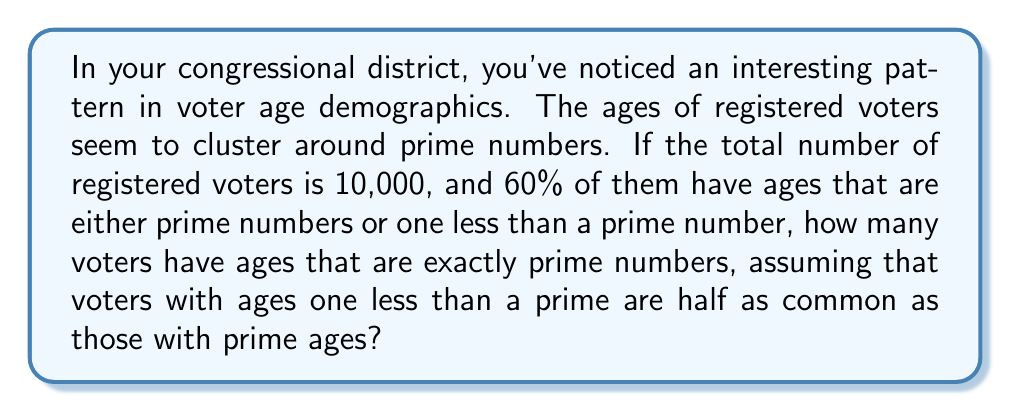Solve this math problem. Let's approach this step-by-step:

1) First, let's define our variables:
   Let $x$ = number of voters with prime ages
   Let $y$ = number of voters with ages one less than a prime

2) We know that $y$ is half of $x$:
   $y = \frac{1}{2}x$

3) We also know that the total number of voters with either prime ages or one less than prime ages is 60% of 10,000:
   $x + y = 0.60 * 10,000 = 6,000$

4) Substituting $y$ with $\frac{1}{2}x$ in the equation from step 3:
   $x + \frac{1}{2}x = 6,000$

5) Simplifying:
   $\frac{3}{2}x = 6,000$

6) Solving for $x$:
   $x = 6,000 * \frac{2}{3} = 4,000$

Therefore, 4,000 voters have ages that are exactly prime numbers.
Answer: 4,000 voters 